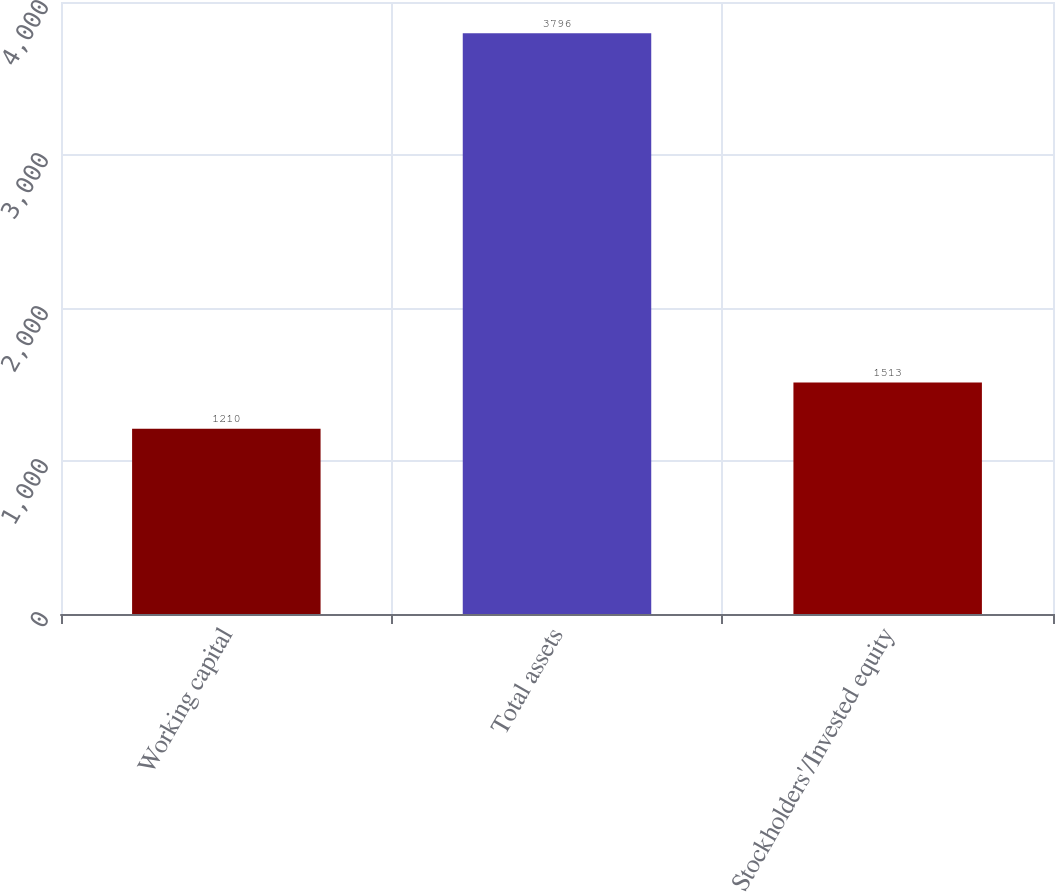Convert chart. <chart><loc_0><loc_0><loc_500><loc_500><bar_chart><fcel>Working capital<fcel>Total assets<fcel>Stockholders'/Invested equity<nl><fcel>1210<fcel>3796<fcel>1513<nl></chart> 